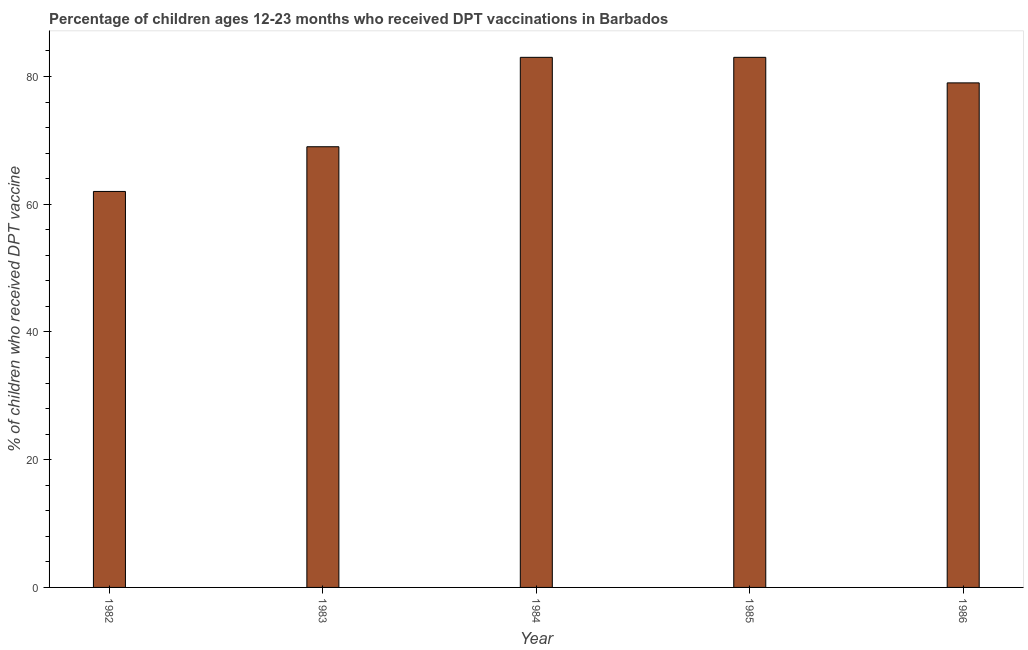Does the graph contain grids?
Make the answer very short. No. What is the title of the graph?
Make the answer very short. Percentage of children ages 12-23 months who received DPT vaccinations in Barbados. What is the label or title of the Y-axis?
Provide a succinct answer. % of children who received DPT vaccine. Across all years, what is the maximum percentage of children who received dpt vaccine?
Give a very brief answer. 83. In which year was the percentage of children who received dpt vaccine maximum?
Provide a short and direct response. 1984. In which year was the percentage of children who received dpt vaccine minimum?
Provide a short and direct response. 1982. What is the sum of the percentage of children who received dpt vaccine?
Your answer should be very brief. 376. What is the difference between the percentage of children who received dpt vaccine in 1982 and 1984?
Offer a very short reply. -21. What is the average percentage of children who received dpt vaccine per year?
Ensure brevity in your answer.  75. What is the median percentage of children who received dpt vaccine?
Ensure brevity in your answer.  79. Do a majority of the years between 1984 and 1985 (inclusive) have percentage of children who received dpt vaccine greater than 68 %?
Your answer should be compact. Yes. What is the ratio of the percentage of children who received dpt vaccine in 1984 to that in 1986?
Offer a very short reply. 1.05. Is the difference between the percentage of children who received dpt vaccine in 1982 and 1985 greater than the difference between any two years?
Offer a terse response. Yes. What is the difference between the highest and the second highest percentage of children who received dpt vaccine?
Your response must be concise. 0. Is the sum of the percentage of children who received dpt vaccine in 1983 and 1984 greater than the maximum percentage of children who received dpt vaccine across all years?
Make the answer very short. Yes. How many bars are there?
Provide a succinct answer. 5. How many years are there in the graph?
Your answer should be compact. 5. Are the values on the major ticks of Y-axis written in scientific E-notation?
Provide a short and direct response. No. What is the % of children who received DPT vaccine of 1982?
Make the answer very short. 62. What is the % of children who received DPT vaccine of 1984?
Provide a succinct answer. 83. What is the % of children who received DPT vaccine in 1985?
Offer a very short reply. 83. What is the % of children who received DPT vaccine of 1986?
Offer a very short reply. 79. What is the difference between the % of children who received DPT vaccine in 1982 and 1984?
Provide a succinct answer. -21. What is the difference between the % of children who received DPT vaccine in 1982 and 1985?
Ensure brevity in your answer.  -21. What is the difference between the % of children who received DPT vaccine in 1982 and 1986?
Your response must be concise. -17. What is the difference between the % of children who received DPT vaccine in 1984 and 1986?
Make the answer very short. 4. What is the ratio of the % of children who received DPT vaccine in 1982 to that in 1983?
Give a very brief answer. 0.9. What is the ratio of the % of children who received DPT vaccine in 1982 to that in 1984?
Keep it short and to the point. 0.75. What is the ratio of the % of children who received DPT vaccine in 1982 to that in 1985?
Offer a terse response. 0.75. What is the ratio of the % of children who received DPT vaccine in 1982 to that in 1986?
Provide a succinct answer. 0.79. What is the ratio of the % of children who received DPT vaccine in 1983 to that in 1984?
Ensure brevity in your answer.  0.83. What is the ratio of the % of children who received DPT vaccine in 1983 to that in 1985?
Your response must be concise. 0.83. What is the ratio of the % of children who received DPT vaccine in 1983 to that in 1986?
Your answer should be compact. 0.87. What is the ratio of the % of children who received DPT vaccine in 1984 to that in 1985?
Make the answer very short. 1. What is the ratio of the % of children who received DPT vaccine in 1984 to that in 1986?
Your response must be concise. 1.05. What is the ratio of the % of children who received DPT vaccine in 1985 to that in 1986?
Provide a succinct answer. 1.05. 